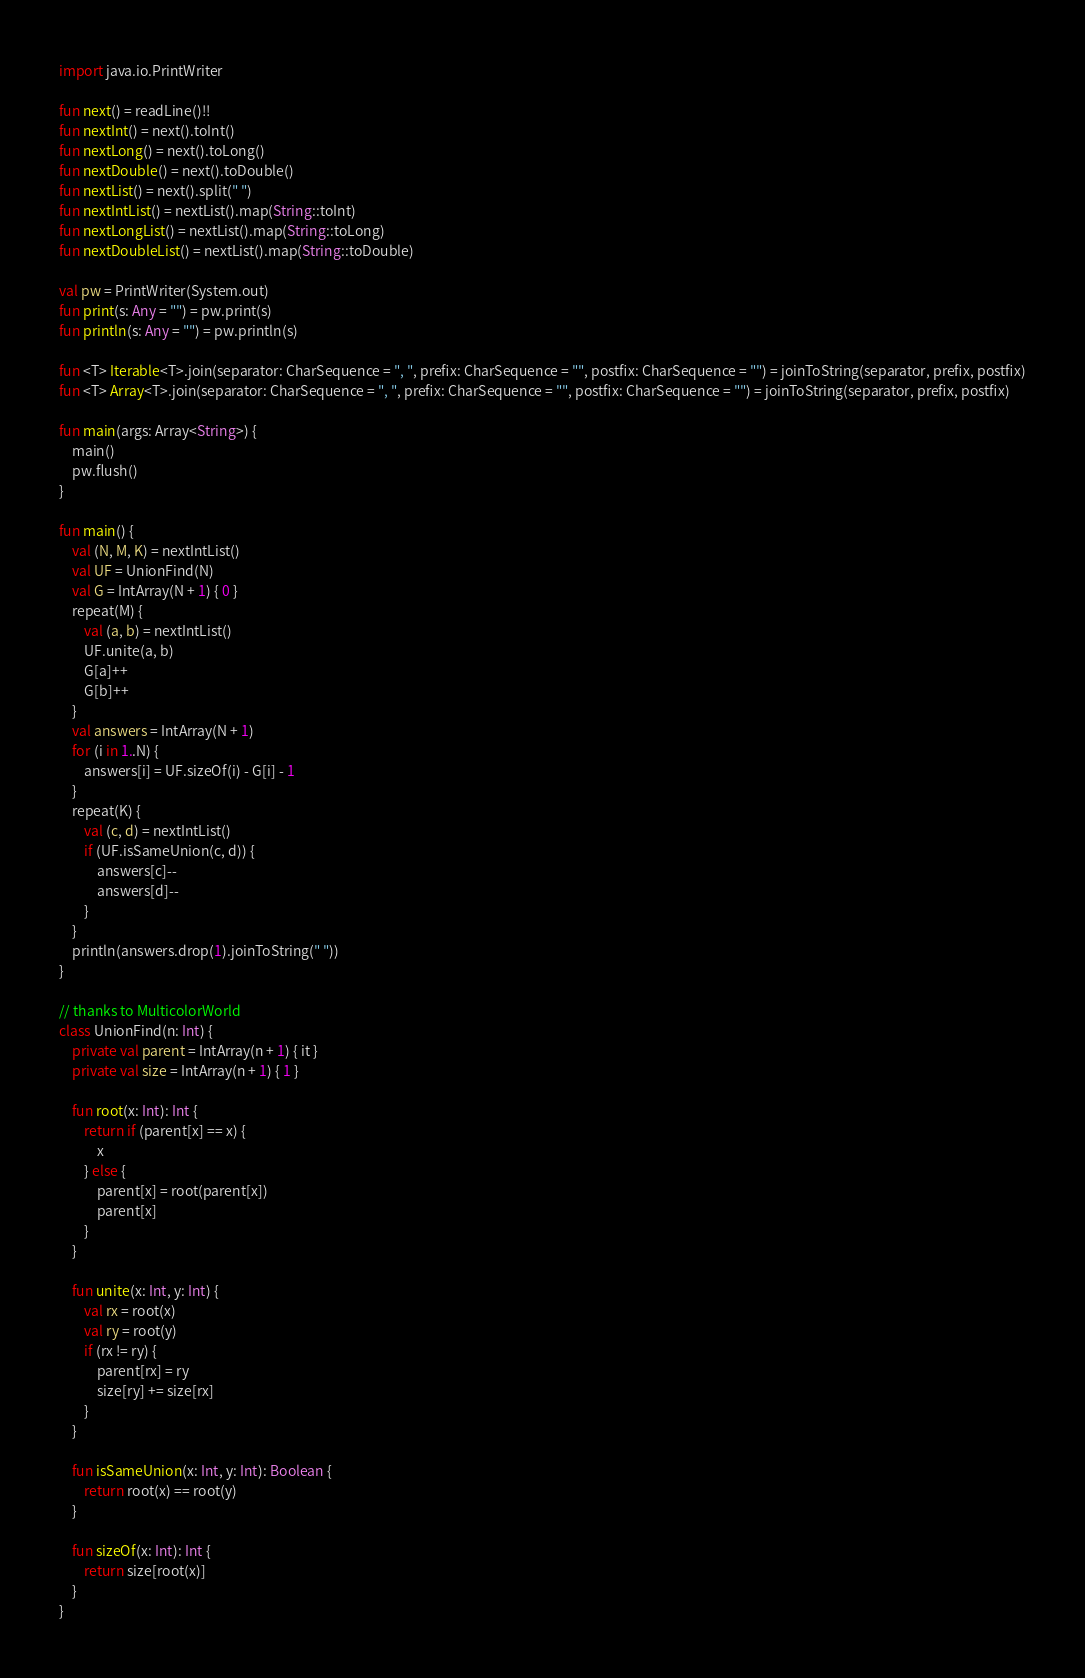Convert code to text. <code><loc_0><loc_0><loc_500><loc_500><_Kotlin_>import java.io.PrintWriter

fun next() = readLine()!!
fun nextInt() = next().toInt()
fun nextLong() = next().toLong()
fun nextDouble() = next().toDouble()
fun nextList() = next().split(" ")
fun nextIntList() = nextList().map(String::toInt)
fun nextLongList() = nextList().map(String::toLong)
fun nextDoubleList() = nextList().map(String::toDouble)

val pw = PrintWriter(System.out)
fun print(s: Any = "") = pw.print(s)
fun println(s: Any = "") = pw.println(s)

fun <T> Iterable<T>.join(separator: CharSequence = ", ", prefix: CharSequence = "", postfix: CharSequence = "") = joinToString(separator, prefix, postfix)
fun <T> Array<T>.join(separator: CharSequence = ", ", prefix: CharSequence = "", postfix: CharSequence = "") = joinToString(separator, prefix, postfix)

fun main(args: Array<String>) {
    main()
    pw.flush()
}

fun main() {
    val (N, M, K) = nextIntList()
    val UF = UnionFind(N)
    val G = IntArray(N + 1) { 0 }
    repeat(M) {
        val (a, b) = nextIntList()
        UF.unite(a, b)
        G[a]++
        G[b]++
    }
    val answers = IntArray(N + 1)
    for (i in 1..N) {
        answers[i] = UF.sizeOf(i) - G[i] - 1
    }
    repeat(K) {
        val (c, d) = nextIntList()
        if (UF.isSameUnion(c, d)) {
            answers[c]--
            answers[d]--
        }
    }
    println(answers.drop(1).joinToString(" "))
}

// thanks to MulticolorWorld
class UnionFind(n: Int) {
    private val parent = IntArray(n + 1) { it }
    private val size = IntArray(n + 1) { 1 }

    fun root(x: Int): Int {
        return if (parent[x] == x) {
            x
        } else {
            parent[x] = root(parent[x])
            parent[x]
        }
    }

    fun unite(x: Int, y: Int) {
        val rx = root(x)
        val ry = root(y)
        if (rx != ry) {
            parent[rx] = ry
            size[ry] += size[rx]
        }
    }

    fun isSameUnion(x: Int, y: Int): Boolean {
        return root(x) == root(y)
    }

    fun sizeOf(x: Int): Int {
        return size[root(x)]
    }
}</code> 